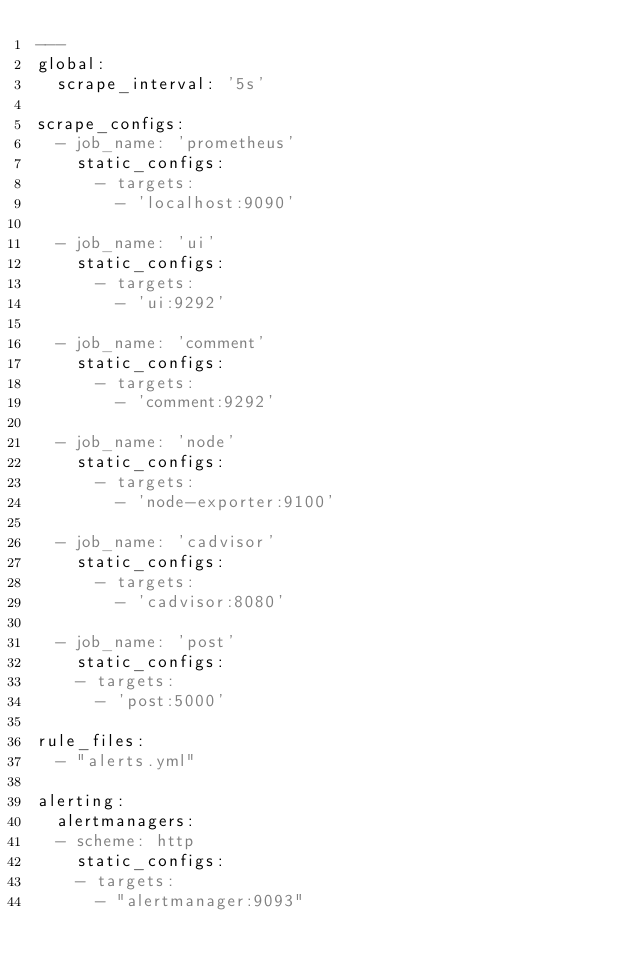<code> <loc_0><loc_0><loc_500><loc_500><_YAML_>---
global:
  scrape_interval: '5s'

scrape_configs:
  - job_name: 'prometheus'
    static_configs:
      - targets:
        - 'localhost:9090'

  - job_name: 'ui'
    static_configs:
      - targets:
        - 'ui:9292'

  - job_name: 'comment'
    static_configs:
      - targets:
        - 'comment:9292'

  - job_name: 'node'
    static_configs:
      - targets:
        - 'node-exporter:9100'

  - job_name: 'cadvisor'
    static_configs:
      - targets:
        - 'cadvisor:8080'

  - job_name: 'post'
    static_configs:
    - targets:
      - 'post:5000'

rule_files:
  - "alerts.yml"

alerting:
  alertmanagers:
  - scheme: http
    static_configs:
    - targets:
      - "alertmanager:9093"
</code> 